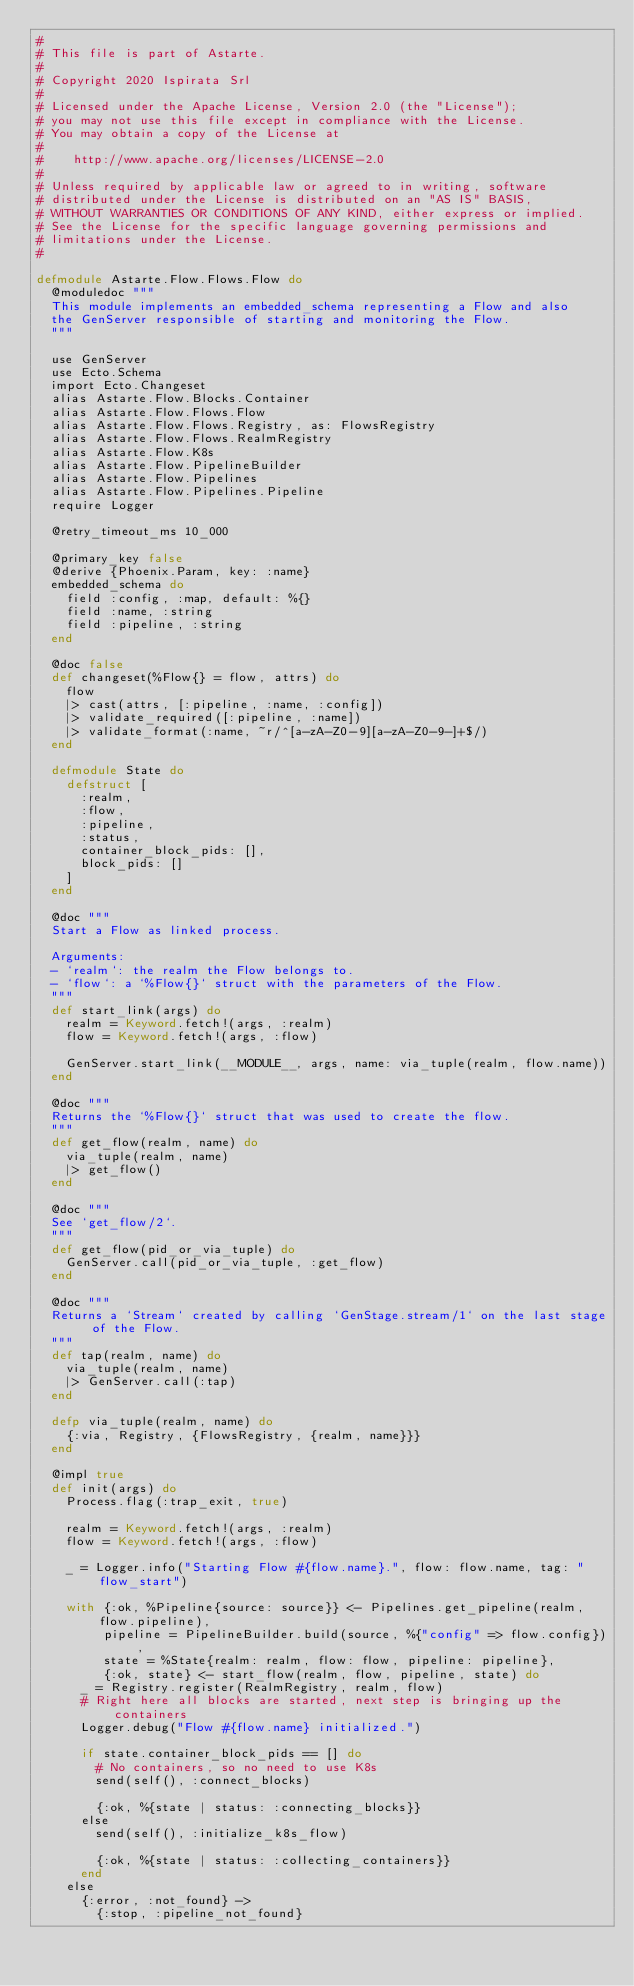Convert code to text. <code><loc_0><loc_0><loc_500><loc_500><_Elixir_>#
# This file is part of Astarte.
#
# Copyright 2020 Ispirata Srl
#
# Licensed under the Apache License, Version 2.0 (the "License");
# you may not use this file except in compliance with the License.
# You may obtain a copy of the License at
#
#    http://www.apache.org/licenses/LICENSE-2.0
#
# Unless required by applicable law or agreed to in writing, software
# distributed under the License is distributed on an "AS IS" BASIS,
# WITHOUT WARRANTIES OR CONDITIONS OF ANY KIND, either express or implied.
# See the License for the specific language governing permissions and
# limitations under the License.
#

defmodule Astarte.Flow.Flows.Flow do
  @moduledoc """
  This module implements an embedded_schema representing a Flow and also
  the GenServer responsible of starting and monitoring the Flow.
  """

  use GenServer
  use Ecto.Schema
  import Ecto.Changeset
  alias Astarte.Flow.Blocks.Container
  alias Astarte.Flow.Flows.Flow
  alias Astarte.Flow.Flows.Registry, as: FlowsRegistry
  alias Astarte.Flow.Flows.RealmRegistry
  alias Astarte.Flow.K8s
  alias Astarte.Flow.PipelineBuilder
  alias Astarte.Flow.Pipelines
  alias Astarte.Flow.Pipelines.Pipeline
  require Logger

  @retry_timeout_ms 10_000

  @primary_key false
  @derive {Phoenix.Param, key: :name}
  embedded_schema do
    field :config, :map, default: %{}
    field :name, :string
    field :pipeline, :string
  end

  @doc false
  def changeset(%Flow{} = flow, attrs) do
    flow
    |> cast(attrs, [:pipeline, :name, :config])
    |> validate_required([:pipeline, :name])
    |> validate_format(:name, ~r/^[a-zA-Z0-9][a-zA-Z0-9-]+$/)
  end

  defmodule State do
    defstruct [
      :realm,
      :flow,
      :pipeline,
      :status,
      container_block_pids: [],
      block_pids: []
    ]
  end

  @doc """
  Start a Flow as linked process.

  Arguments:
  - `realm`: the realm the Flow belongs to.
  - `flow`: a `%Flow{}` struct with the parameters of the Flow.
  """
  def start_link(args) do
    realm = Keyword.fetch!(args, :realm)
    flow = Keyword.fetch!(args, :flow)

    GenServer.start_link(__MODULE__, args, name: via_tuple(realm, flow.name))
  end

  @doc """
  Returns the `%Flow{}` struct that was used to create the flow.
  """
  def get_flow(realm, name) do
    via_tuple(realm, name)
    |> get_flow()
  end

  @doc """
  See `get_flow/2`.
  """
  def get_flow(pid_or_via_tuple) do
    GenServer.call(pid_or_via_tuple, :get_flow)
  end

  @doc """
  Returns a `Stream` created by calling `GenStage.stream/1` on the last stage of the Flow.
  """
  def tap(realm, name) do
    via_tuple(realm, name)
    |> GenServer.call(:tap)
  end

  defp via_tuple(realm, name) do
    {:via, Registry, {FlowsRegistry, {realm, name}}}
  end

  @impl true
  def init(args) do
    Process.flag(:trap_exit, true)

    realm = Keyword.fetch!(args, :realm)
    flow = Keyword.fetch!(args, :flow)

    _ = Logger.info("Starting Flow #{flow.name}.", flow: flow.name, tag: "flow_start")

    with {:ok, %Pipeline{source: source}} <- Pipelines.get_pipeline(realm, flow.pipeline),
         pipeline = PipelineBuilder.build(source, %{"config" => flow.config}),
         state = %State{realm: realm, flow: flow, pipeline: pipeline},
         {:ok, state} <- start_flow(realm, flow, pipeline, state) do
      _ = Registry.register(RealmRegistry, realm, flow)
      # Right here all blocks are started, next step is bringing up the containers
      Logger.debug("Flow #{flow.name} initialized.")

      if state.container_block_pids == [] do
        # No containers, so no need to use K8s
        send(self(), :connect_blocks)

        {:ok, %{state | status: :connecting_blocks}}
      else
        send(self(), :initialize_k8s_flow)

        {:ok, %{state | status: :collecting_containers}}
      end
    else
      {:error, :not_found} ->
        {:stop, :pipeline_not_found}
</code> 